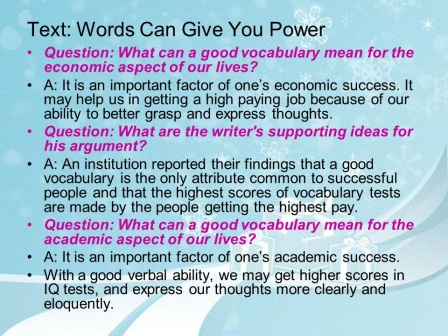This image is very visually striking. What are your thoughts on the design elements? The design elements of the slide are quite engaging and well thought out. The blue background, embellished with white snowflakes, creates a serene and inviting atmosphere. The pink border adds a bright contrast that draws attention without being overwhelming. This combination of colors and patterns helps the text stand out while maintaining a balanced visual appeal. The strategic use of different font colors for the title and questions enhances readability and highlights key sections, making the information easy to follow. How could these design elements be tweaked to make the slide even more effective? To make the slide even more effective, a few tweaks could be considered. For example, increasing the font size slightly may improve readability, especially for those viewing the presentation from a distance. Additionally, adding visual aids such as icons or infographics next to each question and answer could break up text blocks and make the content more engaging. Ensuring a high-contrast color scheme throughout would also enhance visibility, especially for viewers with visual impairments. Finally, incorporating a subtle gradient in the background might add depth without detracting from the main content. 